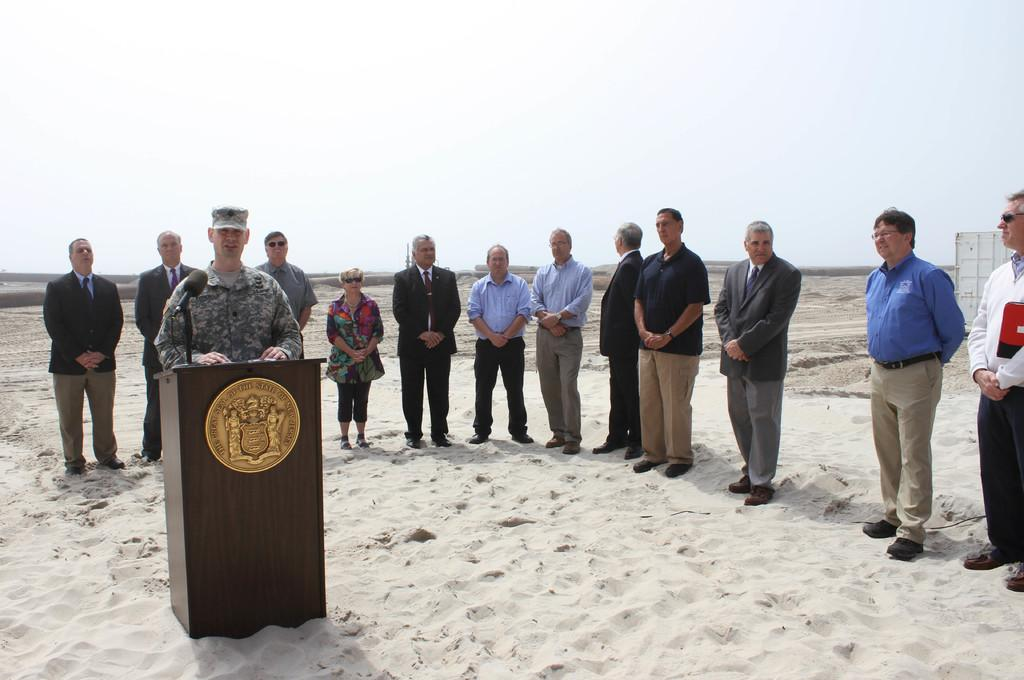What is the surface on which the people are standing in the image? The people are standing on the sand. Can you describe the position of the person on the left side of the image? A person is standing at the left side of the image. What type of clothing is the person wearing? The person is wearing an army uniform. What object is visible in the image that is typically used for amplifying sound? There is a microphone in the image. What is in front of the person with the microphone? There is a table in front of the person with the microphone. How does the person with the microphone plan to expand their debt in the image? There is no mention of debt or expansion in the image; the focus is on the person with the microphone and the table in front of them. 